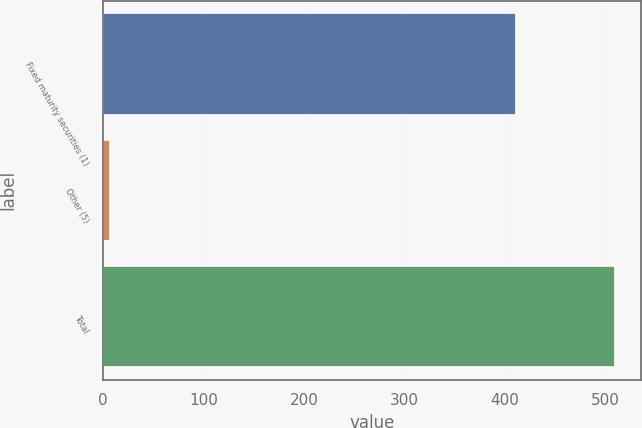Convert chart to OTSL. <chart><loc_0><loc_0><loc_500><loc_500><bar_chart><fcel>Fixed maturity securities (1)<fcel>Other (5)<fcel>Total<nl><fcel>411<fcel>7.3<fcel>509.3<nl></chart> 